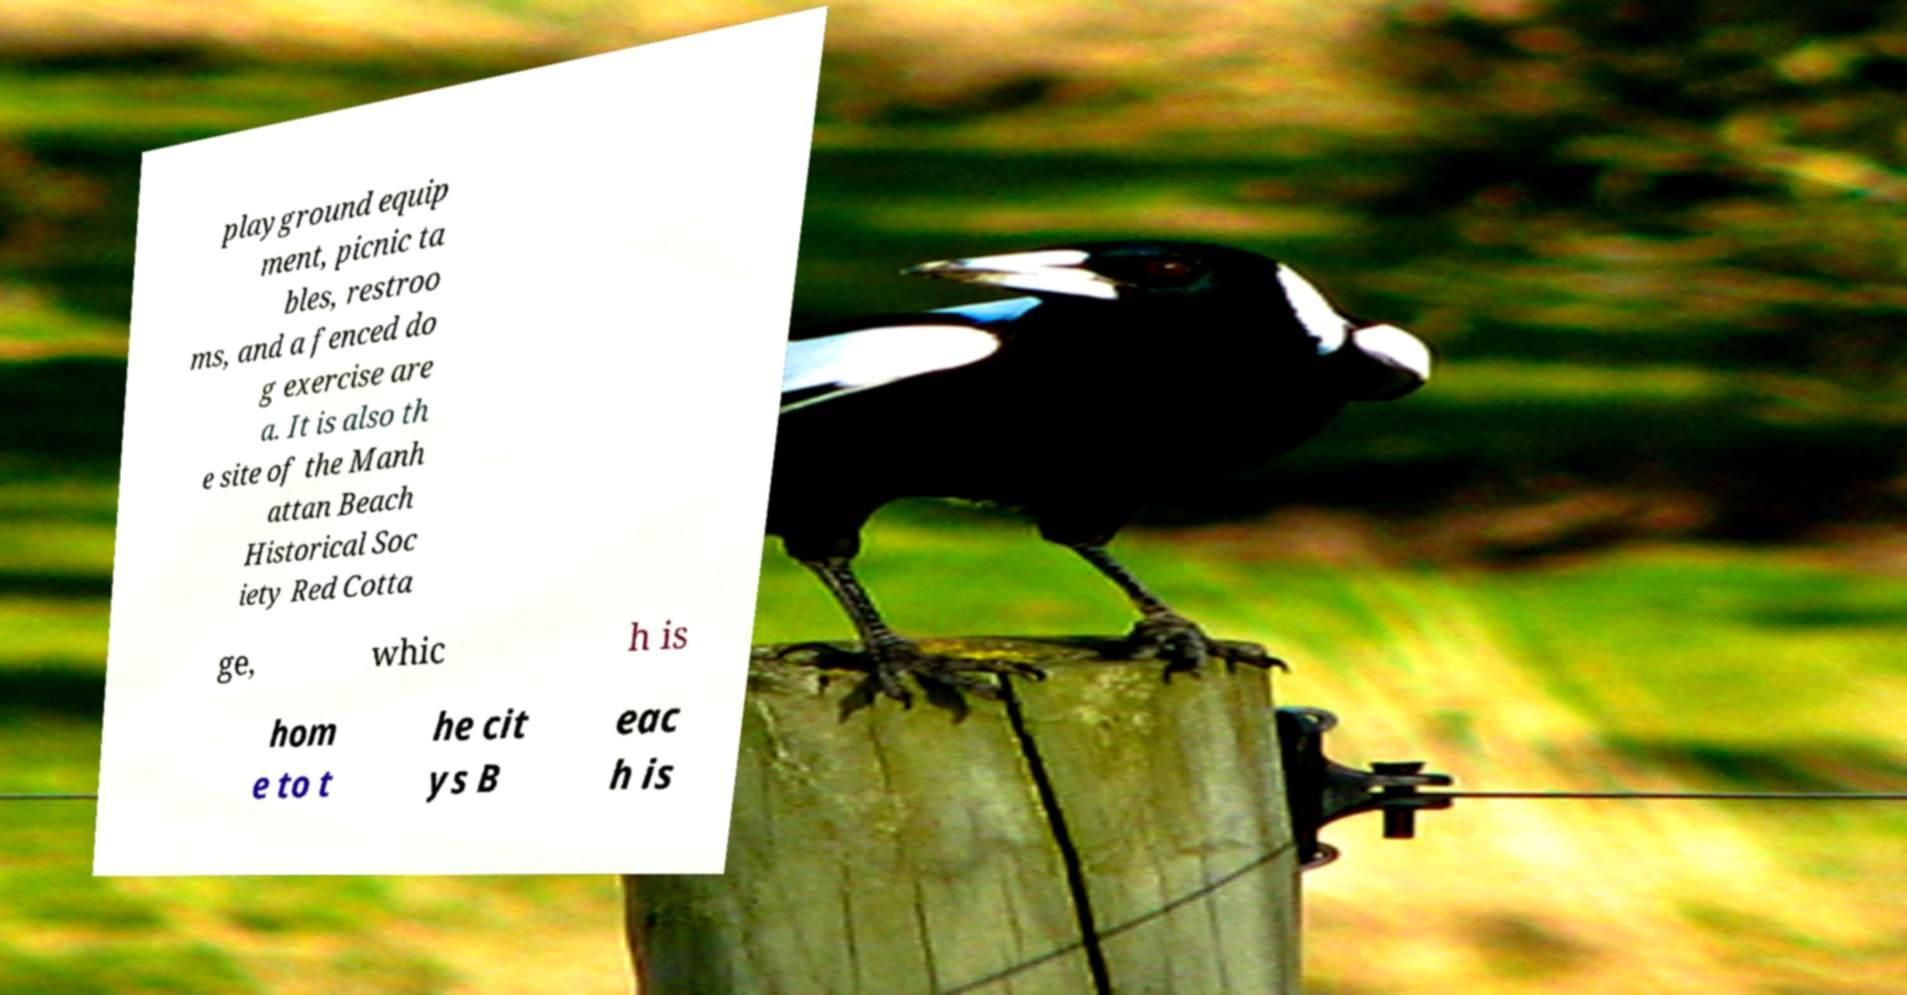Could you assist in decoding the text presented in this image and type it out clearly? playground equip ment, picnic ta bles, restroo ms, and a fenced do g exercise are a. It is also th e site of the Manh attan Beach Historical Soc iety Red Cotta ge, whic h is hom e to t he cit ys B eac h is 